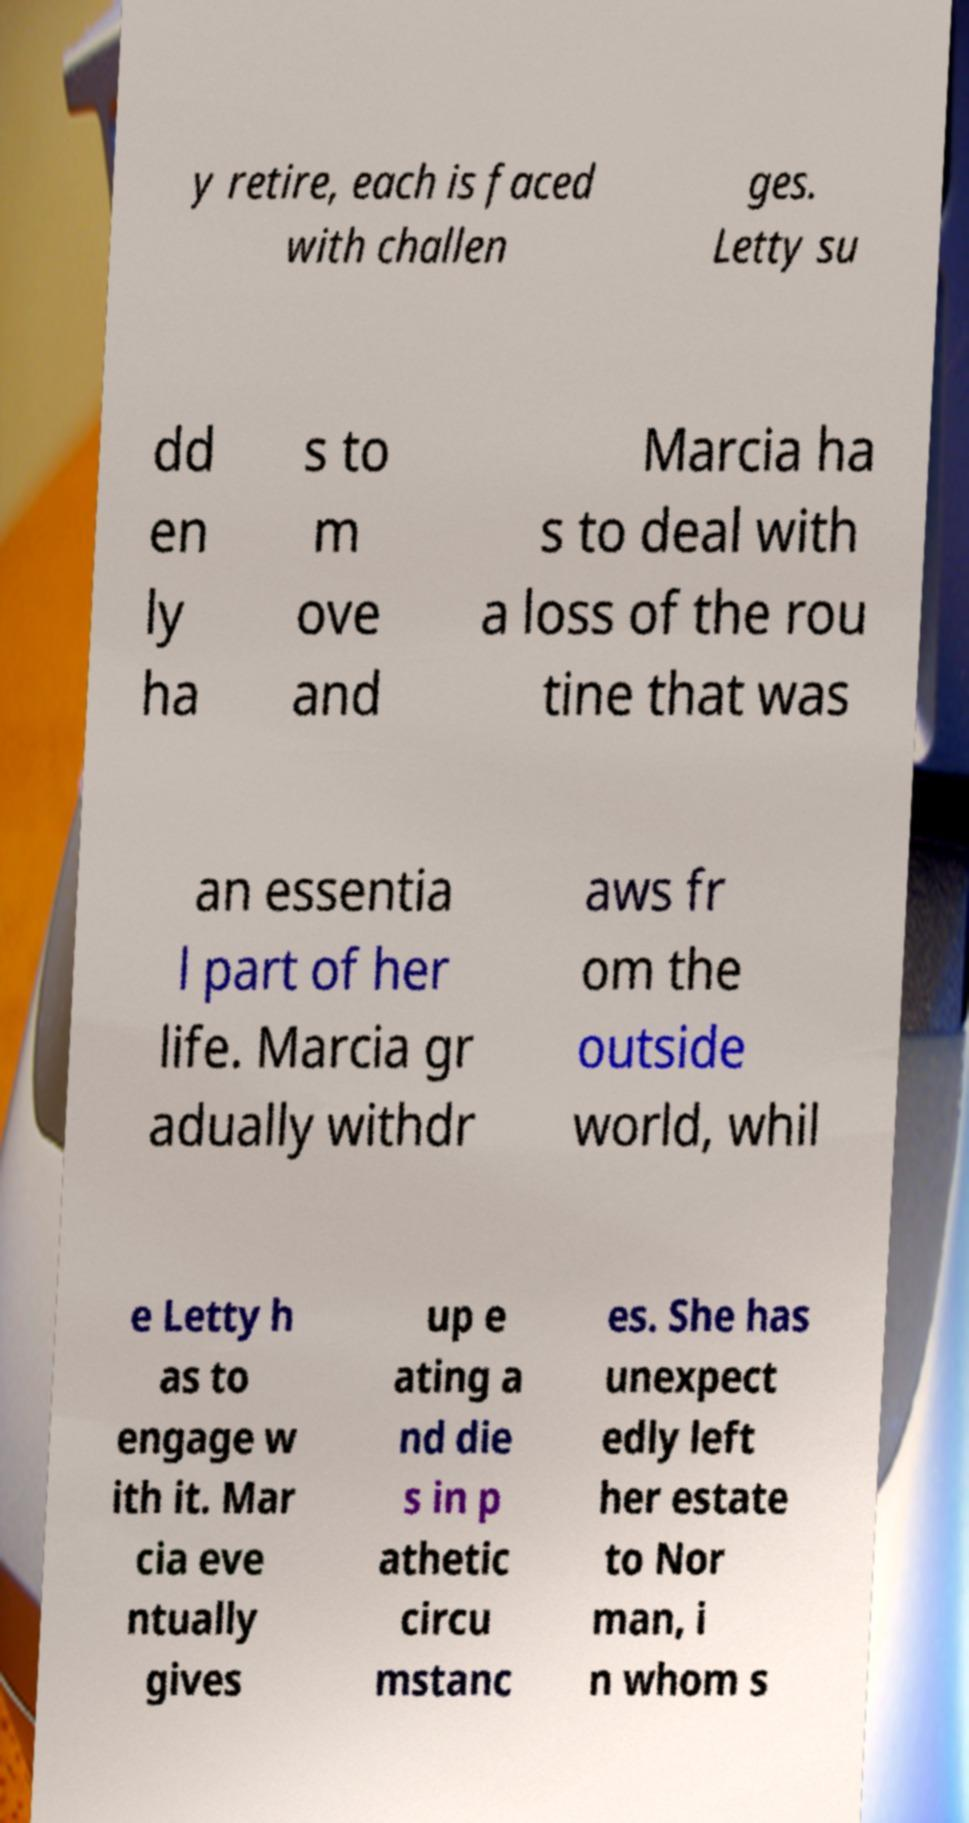What messages or text are displayed in this image? I need them in a readable, typed format. y retire, each is faced with challen ges. Letty su dd en ly ha s to m ove and Marcia ha s to deal with a loss of the rou tine that was an essentia l part of her life. Marcia gr adually withdr aws fr om the outside world, whil e Letty h as to engage w ith it. Mar cia eve ntually gives up e ating a nd die s in p athetic circu mstanc es. She has unexpect edly left her estate to Nor man, i n whom s 